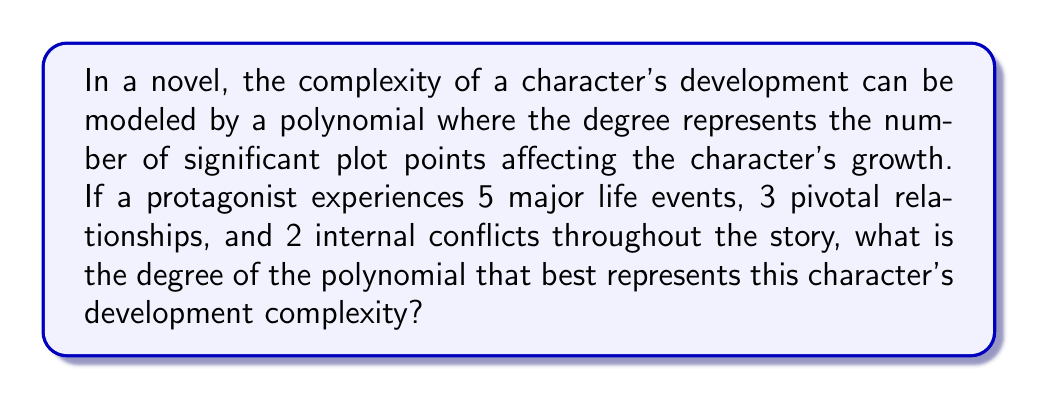What is the answer to this math problem? To determine the degree of the polynomial modeling character development complexity, we need to follow these steps:

1. Identify the components contributing to character development:
   - Major life events: 5
   - Pivotal relationships: 3
   - Internal conflicts: 2

2. Sum up all the components:
   $$ \text{Total components} = 5 + 3 + 2 = 10 $$

3. In polynomial arithmetic, the degree of a polynomial is the highest power of the variable. In this context, each component of character development contributes to the complexity, and the total number of components determines the highest power (degree) of the polynomial.

4. Therefore, the degree of the polynomial representing this character's development complexity is equal to the total number of components:
   $$ \text{Degree} = 10 $$

This means the character's development could be represented by a 10th-degree polynomial, where each term corresponds to a specific aspect of their growth throughout the story.
Answer: 10 